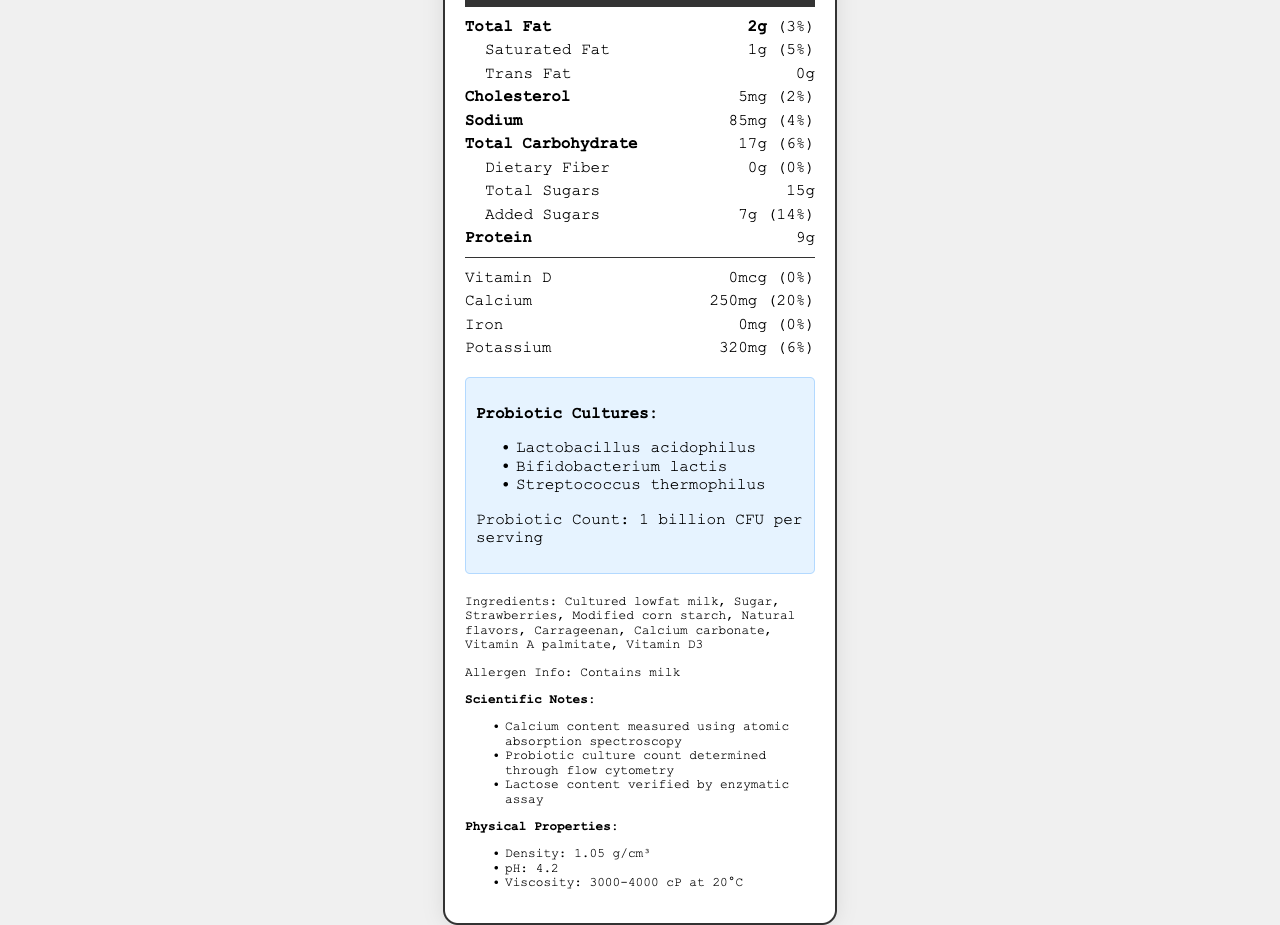what is the serving size of LightLife Low-Fat Probiotic Yogurt? The serving size is indicated at the top of the Nutrition Facts label.
Answer: 170g (3/4 cup) How many servings are there per container? The document states that there are 4 servings per container.
Answer: 4 What is the amount of calcium in one serving of this yogurt? The calcium amount is listed under the vitamins and minerals section.
Answer: 250mg What are the probiotic cultures present in this yogurt? The probiotic cultures are listed in a specific section highlighting them.
Answer: Lactobacillus acidophilus, Bifidobacterium lactis, Streptococcus thermophilus How much protein does one serving of this yogurt contain? The protein content per serving is listed in the document.
Answer: 9g What is the pH value of this yogurt? The pH value is mentioned under the physical properties section.
Answer: 4.2 Does the yogurt contain added sugars? The document states there are 7g of added sugars per serving.
Answer: Yes What is the percentage of the daily value for calcium provided by one serving of this yogurt? A. 15% B. 20% C. 25% The document states that one serving provides 20% of the daily value for calcium.
Answer: B. 20% Which of the following is not an ingredient in the yogurt? A. Cultured lowfat milk B. Honey C. Strawberries Honey is not listed among the ingredients; strawberries and cultured lowfat milk are.
Answer: B. Honey Is there any dietary fiber in one serving of this yogurt? The document states that there is 0g of dietary fiber per serving.
Answer: No Summarize the main idea of the document. The document serves to inform consumers about the nutritional content and properties of the yogurt, including its probiotic benefits and allergen information.
Answer: The document provides nutritional information for LightLife Low-Fat Probiotic Yogurt. It includes details such as serving size, calories, macronutrients, vitamins, minerals, probiotic cultures, and ingredients. It also lists scientific notes and physical properties of the yogurt. How is the calcium content measured in this yogurt? The scientific notes mention that the calcium content is measured using atomic absorption spectroscopy.
Answer: Atomic absorption spectroscopy What is the viscosity range of this yogurt at 20°C? The viscosity is mentioned in the physical properties section and falls within the range of 3000-4000 cP.
Answer: 3000-4000 cP What is the total carbohydrate content per serving? The label indicates that one serving contains 17g of total carbohydrates.
Answer: 17g How many calories are there in the entire container of yogurt? Since the container has 4 servings and each serving is 110 calories, the total would be 110 calories x 4 servings = 440 calories.
Answer: 440 calories Based on the document, what is the method used to determine the probiotic culture count? The scientific notes section states that flow cytometry is used to determine the probiotic culture count.
Answer: Flow cytometry What is the total fat percentage of the daily value provided by one serving? A. 3% B. 6% C. 10% The document states that the total fat content contributes to 3% of the daily value.
Answer: A. 3% Which of the following is a source of added sugar in the yogurt? A. Cultured lowfat milk B. Sugar C. Natural flavors Sugar is listed as one of the ingredients, contributing to the added sugars in the yogurt.
Answer: B. Sugar What is the amount of vitamin D in one serving? The document states that there is 0mcg of vitamin D per serving.
Answer: 0mcg Are there any iron content in one serving of this yogurt? The document indicates that there is 0mg of iron per serving.
Answer: No How much cholesterol is present in one serving of this yogurt? The cholesterol content per serving is listed in the document.
Answer: 5mg What method is used to verify the lactose content? The scientific notes section mentions that the lactose content is verified by enzymatic assay.
Answer: Enzymatic assay Can you determine the origin of the milk used in the yogurt from the document? The document does not provide any information about the origin of the milk used in the yogurt.
Answer: Not enough information 